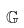Convert formula to latex. <formula><loc_0><loc_0><loc_500><loc_500>\mathbb { G }</formula> 